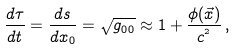<formula> <loc_0><loc_0><loc_500><loc_500>\frac { d \tau } { d t } = \frac { d s } { d x _ { 0 } } = \sqrt { g _ { 0 0 } } \approx 1 + \frac { \phi ( \vec { x } ) } { c ^ { ^ { 2 } } } \, ,</formula> 